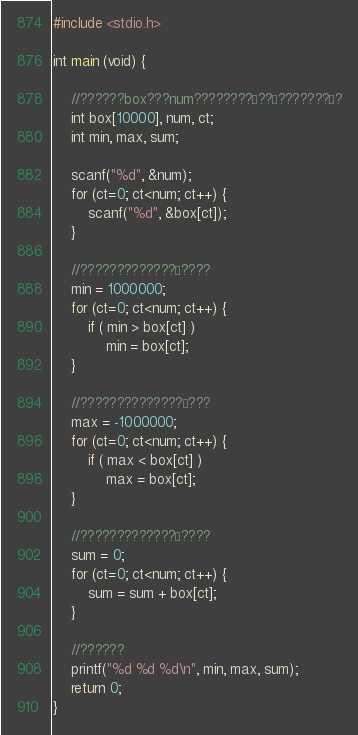Convert code to text. <code><loc_0><loc_0><loc_500><loc_500><_C_>#include <stdio.h>

int main (void) {
 	
 	//??????box???num????????´??°???????´?
	int box[10000], num, ct;
	int min, max, sum;

	scanf("%d", &num);
	for (ct=0; ct<num; ct++) {
		scanf("%d", &box[ct]);
	}

	//?????????????°????
	min = 1000000;
	for (ct=0; ct<num; ct++) {
		if ( min > box[ct] )
			min = box[ct];
	}

	//??????????????§???
	max = -1000000;
	for (ct=0; ct<num; ct++) {
		if ( max < box[ct] )
			max = box[ct];
	}

	//?????????????¨????
	sum = 0;
	for (ct=0; ct<num; ct++) {
		sum = sum + box[ct];
	}

	//??????
	printf("%d %d %d\n", min, max, sum);
	return 0;
}</code> 